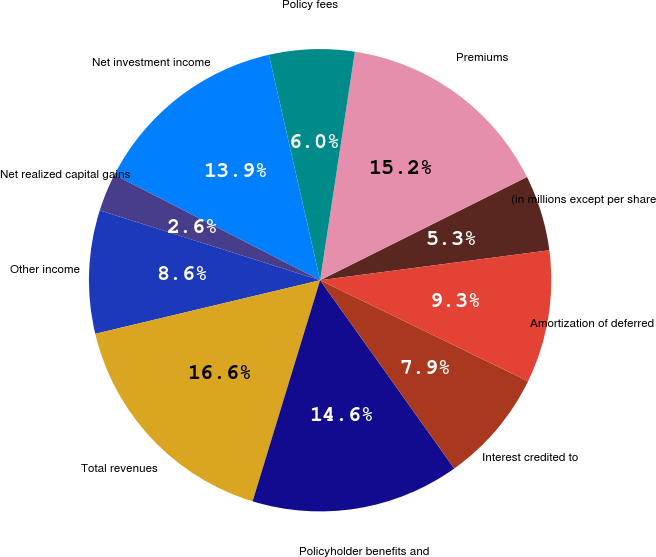Convert chart to OTSL. <chart><loc_0><loc_0><loc_500><loc_500><pie_chart><fcel>(in millions except per share<fcel>Premiums<fcel>Policy fees<fcel>Net investment income<fcel>Net realized capital gains<fcel>Other income<fcel>Total revenues<fcel>Policyholder benefits and<fcel>Interest credited to<fcel>Amortization of deferred<nl><fcel>5.3%<fcel>15.23%<fcel>5.96%<fcel>13.91%<fcel>2.65%<fcel>8.61%<fcel>16.56%<fcel>14.57%<fcel>7.95%<fcel>9.27%<nl></chart> 